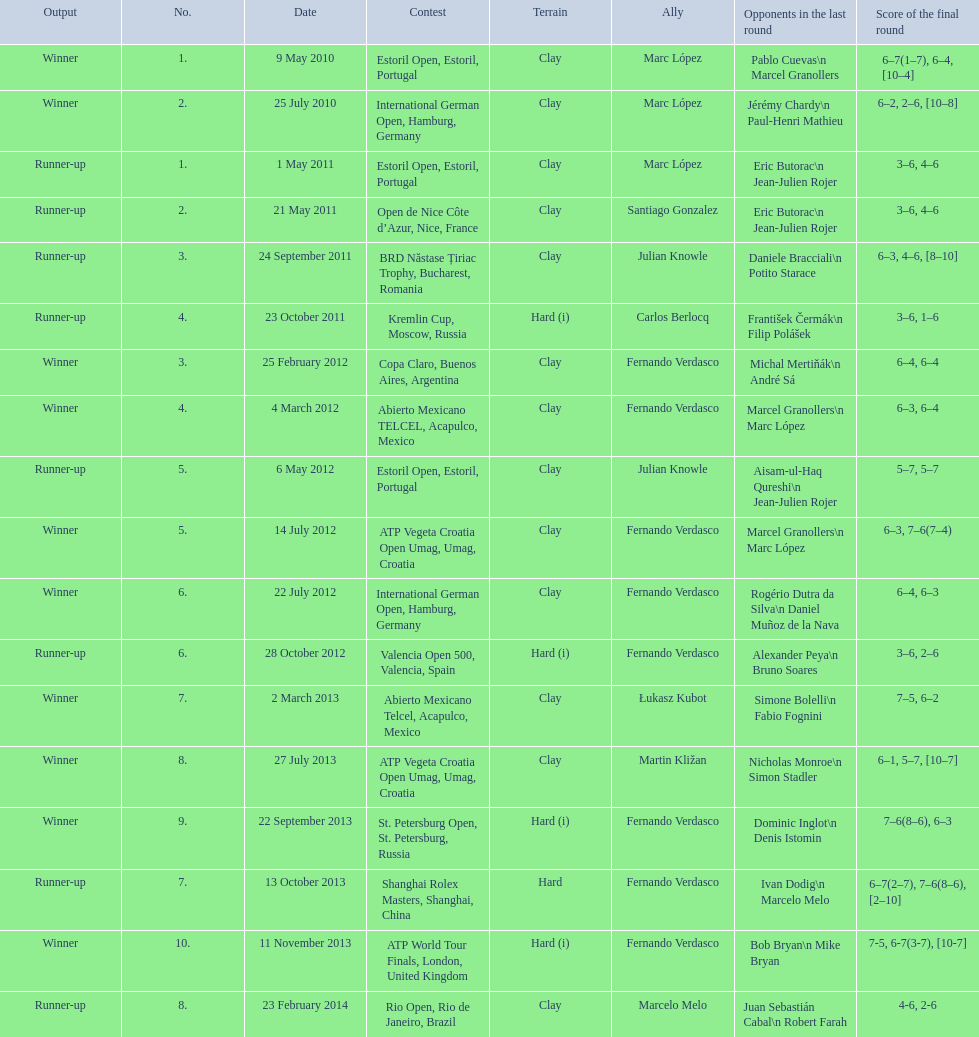How many partners from spain are listed? 2. 